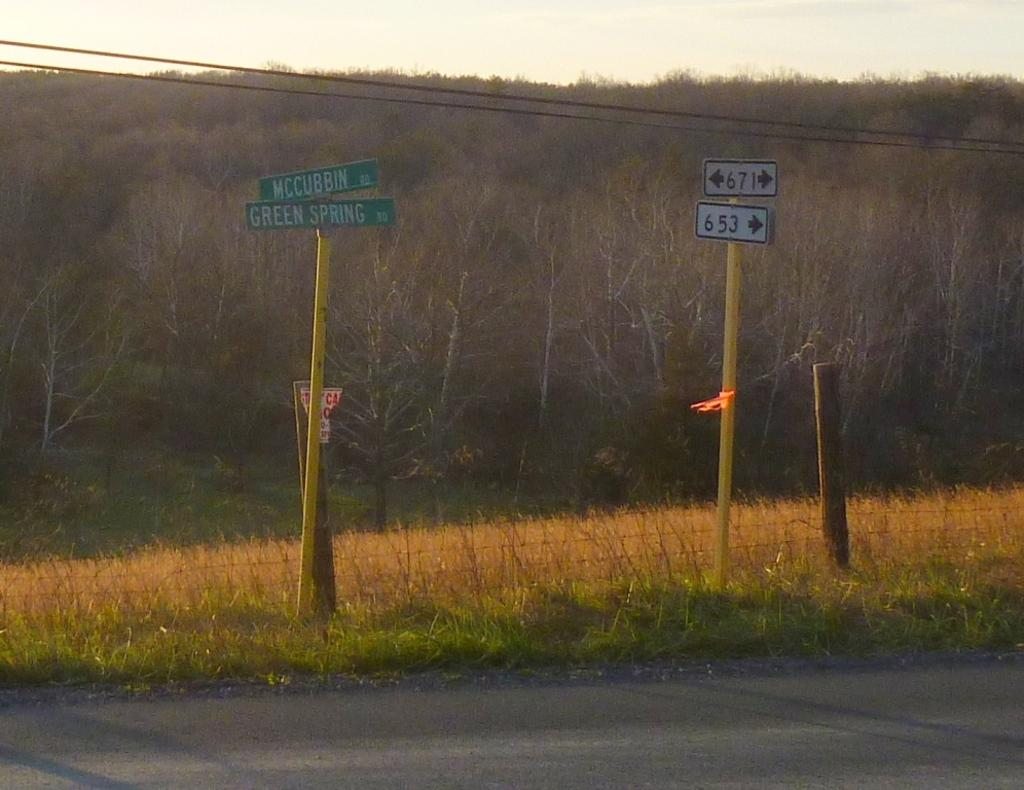What type of surface can be seen in the image? There is a road in the image. What type of vegetation is present in the image? There is grass and trees in the image. What structure can be seen in the image? There is a pole in the image. What object is present for displaying information or advertisements? There is a board in the image. What else can be seen in the image related to infrastructure? There are electric wires in the image. What part of the natural environment is visible in the image? The sky is visible in the image. What type of wine is being served in the image? There is no wine present in the image. What nut is being cracked open in the image? There are no nuts present in the image. 